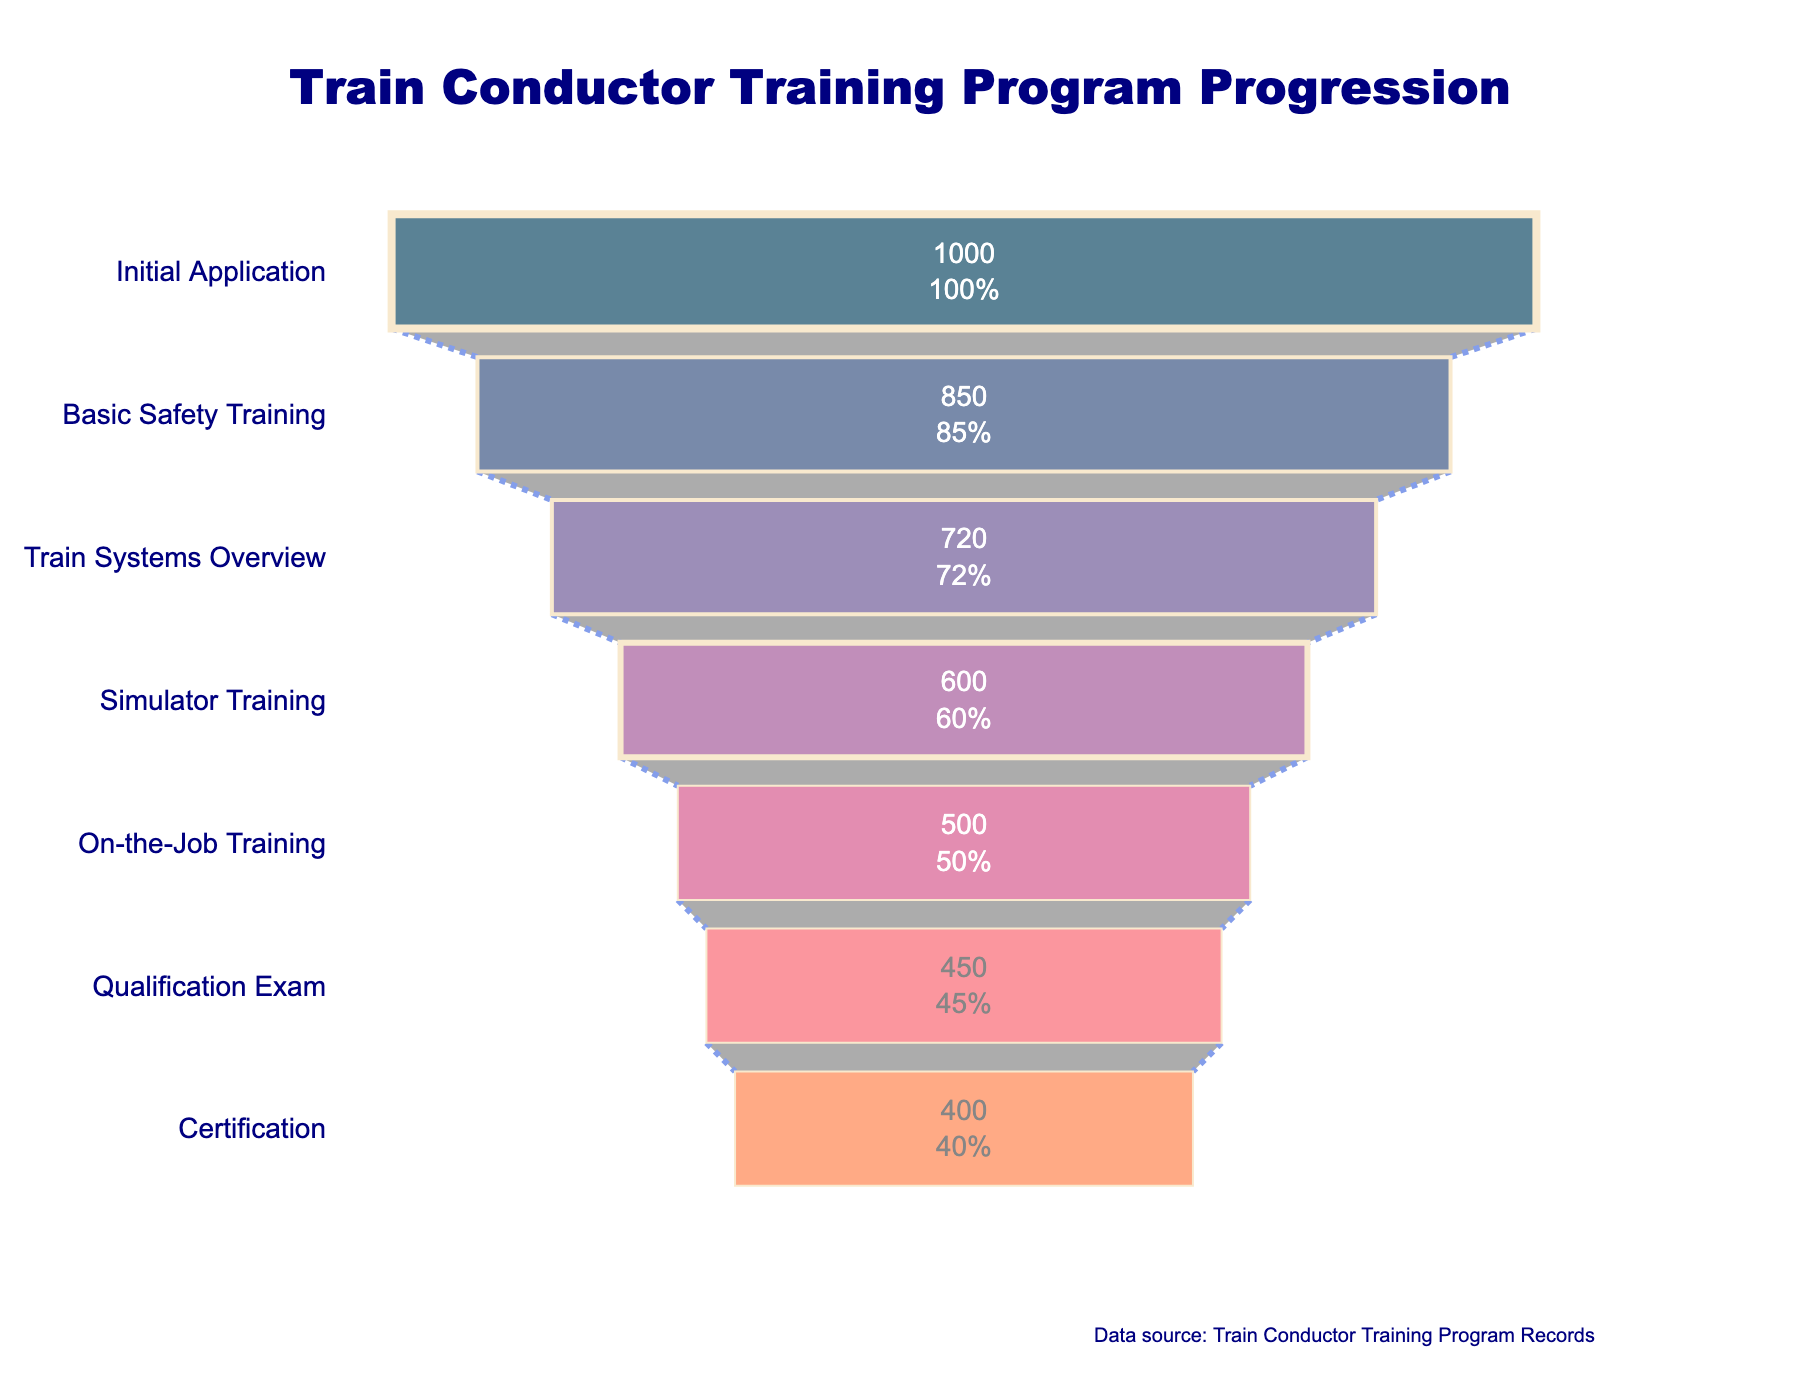What is the title of the funnel chart? The title is located at the top of the chart and should communicate the main idea or focus of the visualization. Here, it states "Train Conductor Training Program Progression."
Answer: Train Conductor Training Program Progression Which stage has the highest number of participants? Observing the funnel chart, the initial stage, "Initial Application," has the largest width and lists 1000 participants.
Answer: Initial Application How many participants completed the Certification stage? The Certification stage is the last stage in the funnel and shows a total of 400 participants.
Answer: 400 What is the percentage of participants that made it to the Simulator Training stage out of the Initial Application stage? The number of participants in the Simulator Training stage is 600. The initial stage has 1000 participants. The percentage is calculated as (600/1000) * 100 = 60%.
Answer: 60% How many participants did not pass the Qualification Exam? The number of participants reaching the Qualification Exam is 450. Since the previous stage, On-the-Job Training, has 500 participants, the difference indicates the dropouts: 500 - 450 = 50.
Answer: 50 Which stage has the largest drop in participants? By comparing the decline in participants between consecutive stages, the largest drop can be measured. The drop from Basic Safety Training (850) to Train Systems Overview (720) is the largest (130 participants).
Answer: Between Basic Safety Training and Train Systems Overview How many participants advanced from the Train Systems Overview to Simulator Training? The number of participants in Train Systems Overview is 720, and the number in Simulator Training is 600. The difference shows the number who advanced directly: 720 - 600 = 120.
Answer: 120 What percentage of participants completed the Basic Safety Training stage? 850 participants completed the Basic Safety Training stage, starting from 1000 in the Initial Application. The percentage is (850/1000) * 100 = 85%.
Answer: 85% Which stage comes directly after Simulator Training? Observing the sequence of stages in the funnel chart, "On-the-Job Training" follows directly after "Simulator Training."
Answer: On-the-Job Training Do more participants drop out between the Initial Application and Basic Safety Training, or between On-the-Job Training and the Qualification Exam? Initial Application to Basic Safety Training drops from 1000 to 850 (150 dropouts), and On-the-Job Training to Qualification Exam drops from 500 to 450 (50 dropouts). Thus, the first stage has more dropouts.
Answer: Initial Application to Basic Safety Training 